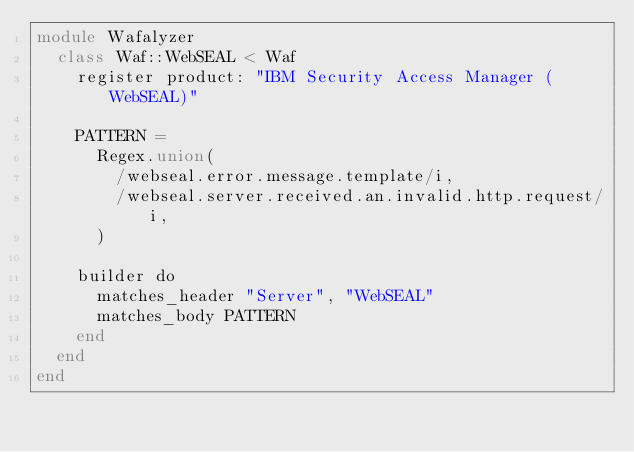<code> <loc_0><loc_0><loc_500><loc_500><_Crystal_>module Wafalyzer
  class Waf::WebSEAL < Waf
    register product: "IBM Security Access Manager (WebSEAL)"

    PATTERN =
      Regex.union(
        /webseal.error.message.template/i,
        /webseal.server.received.an.invalid.http.request/i,
      )

    builder do
      matches_header "Server", "WebSEAL"
      matches_body PATTERN
    end
  end
end
</code> 